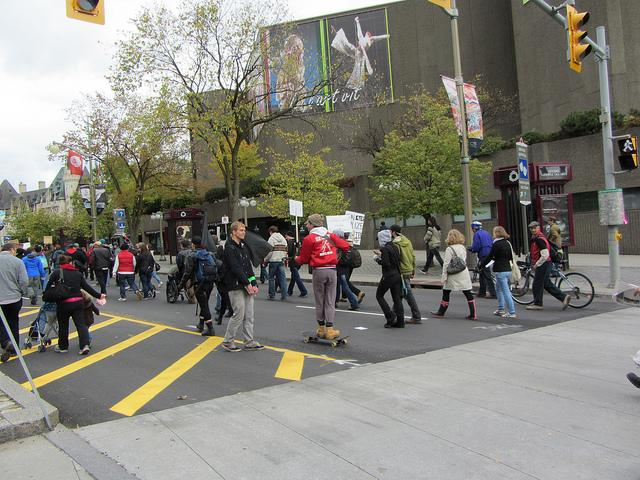What type of area is shown? Please explain your reasoning. public. The place is open with a lot of streets. 